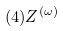<formula> <loc_0><loc_0><loc_500><loc_500>( 4 ) Z ^ { ( \omega ) }</formula> 